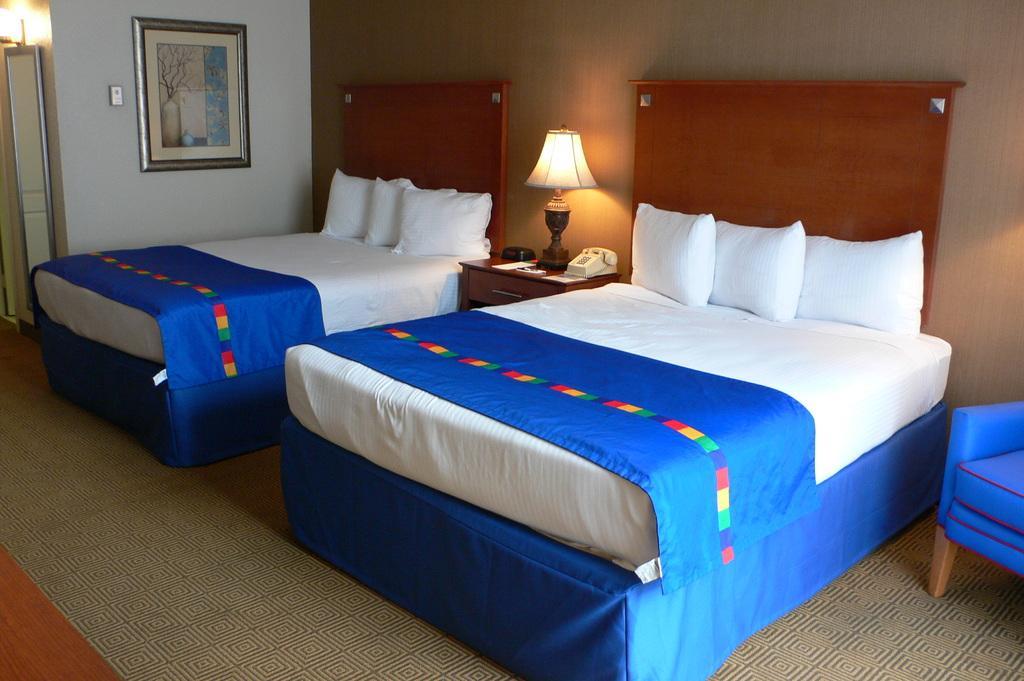Can you describe this image briefly? There are two beds and a lamp in between them in a room. 